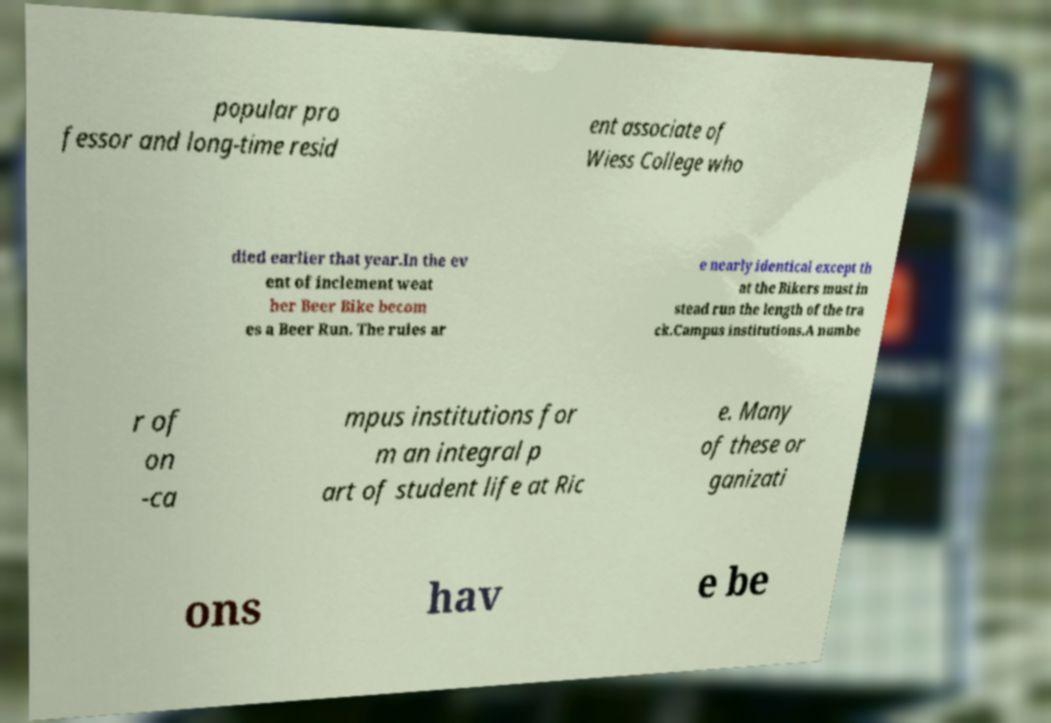Can you read and provide the text displayed in the image?This photo seems to have some interesting text. Can you extract and type it out for me? popular pro fessor and long-time resid ent associate of Wiess College who died earlier that year.In the ev ent of inclement weat her Beer Bike becom es a Beer Run. The rules ar e nearly identical except th at the Bikers must in stead run the length of the tra ck.Campus institutions.A numbe r of on -ca mpus institutions for m an integral p art of student life at Ric e. Many of these or ganizati ons hav e be 